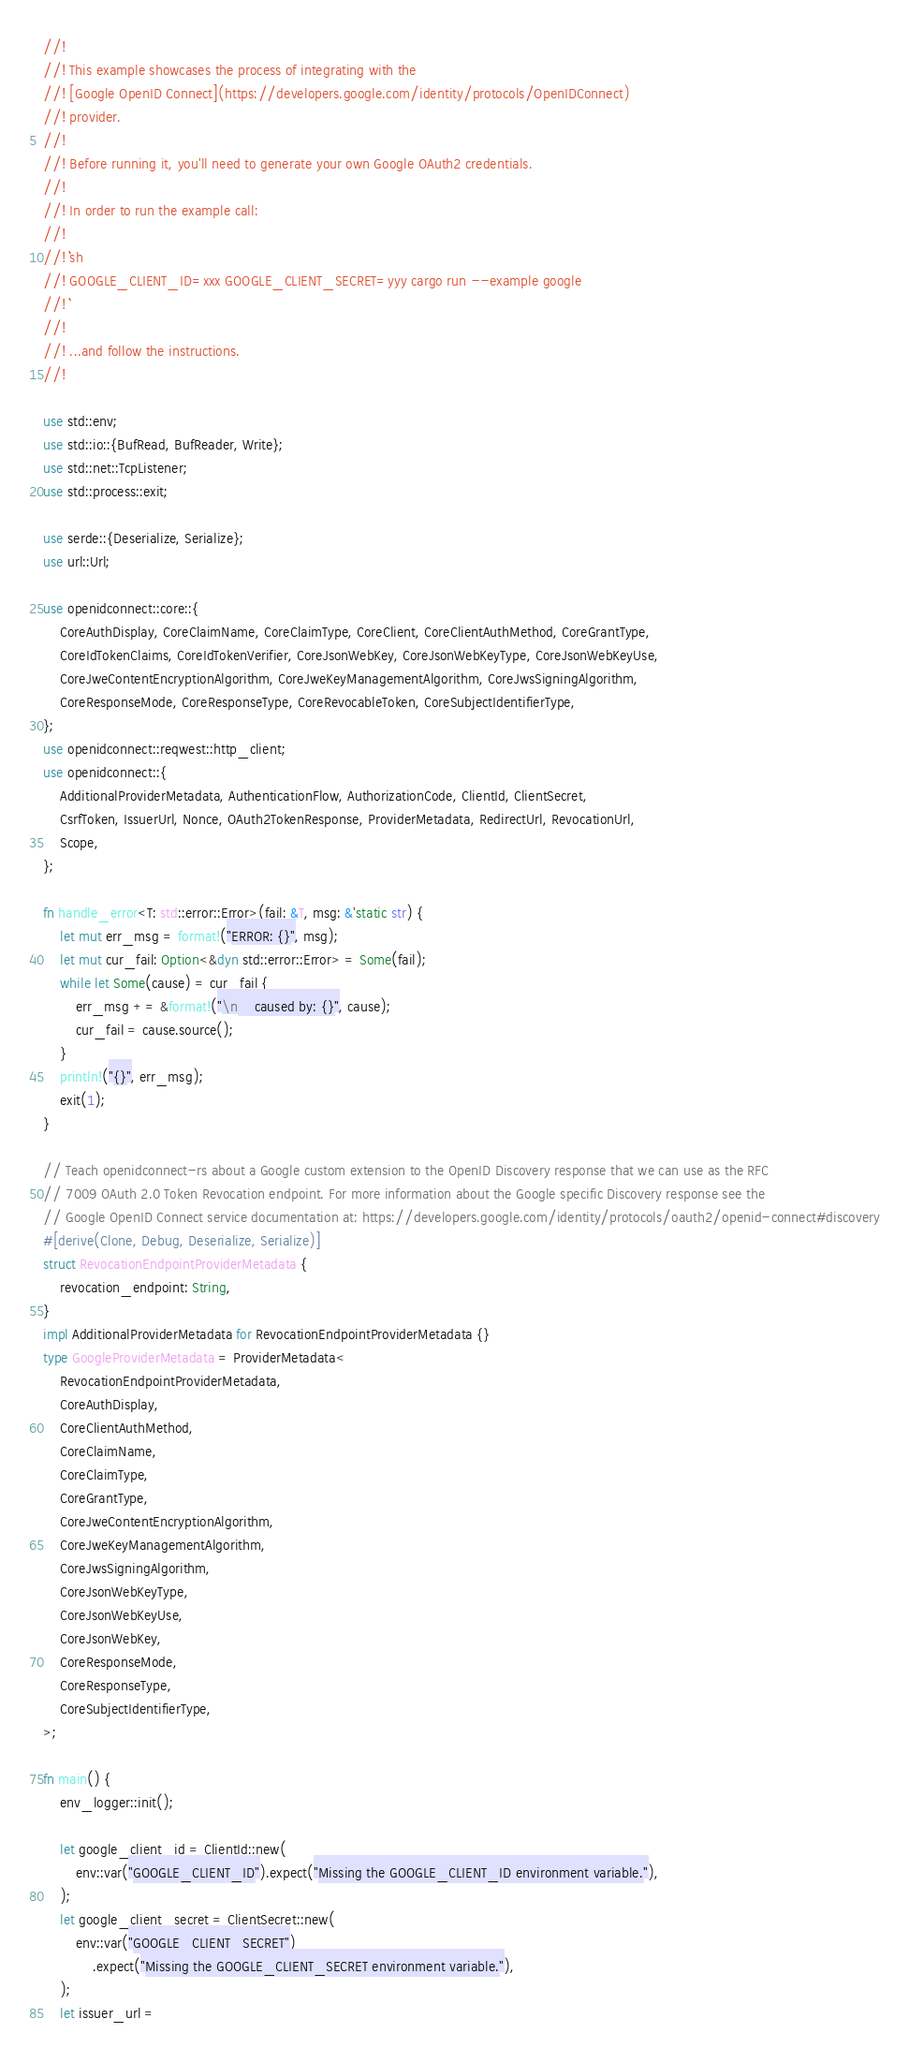<code> <loc_0><loc_0><loc_500><loc_500><_Rust_>//!
//! This example showcases the process of integrating with the
//! [Google OpenID Connect](https://developers.google.com/identity/protocols/OpenIDConnect)
//! provider.
//!
//! Before running it, you'll need to generate your own Google OAuth2 credentials.
//!
//! In order to run the example call:
//!
//! ```sh
//! GOOGLE_CLIENT_ID=xxx GOOGLE_CLIENT_SECRET=yyy cargo run --example google
//! ```
//!
//! ...and follow the instructions.
//!

use std::env;
use std::io::{BufRead, BufReader, Write};
use std::net::TcpListener;
use std::process::exit;

use serde::{Deserialize, Serialize};
use url::Url;

use openidconnect::core::{
    CoreAuthDisplay, CoreClaimName, CoreClaimType, CoreClient, CoreClientAuthMethod, CoreGrantType,
    CoreIdTokenClaims, CoreIdTokenVerifier, CoreJsonWebKey, CoreJsonWebKeyType, CoreJsonWebKeyUse,
    CoreJweContentEncryptionAlgorithm, CoreJweKeyManagementAlgorithm, CoreJwsSigningAlgorithm,
    CoreResponseMode, CoreResponseType, CoreRevocableToken, CoreSubjectIdentifierType,
};
use openidconnect::reqwest::http_client;
use openidconnect::{
    AdditionalProviderMetadata, AuthenticationFlow, AuthorizationCode, ClientId, ClientSecret,
    CsrfToken, IssuerUrl, Nonce, OAuth2TokenResponse, ProviderMetadata, RedirectUrl, RevocationUrl,
    Scope,
};

fn handle_error<T: std::error::Error>(fail: &T, msg: &'static str) {
    let mut err_msg = format!("ERROR: {}", msg);
    let mut cur_fail: Option<&dyn std::error::Error> = Some(fail);
    while let Some(cause) = cur_fail {
        err_msg += &format!("\n    caused by: {}", cause);
        cur_fail = cause.source();
    }
    println!("{}", err_msg);
    exit(1);
}

// Teach openidconnect-rs about a Google custom extension to the OpenID Discovery response that we can use as the RFC
// 7009 OAuth 2.0 Token Revocation endpoint. For more information about the Google specific Discovery response see the
// Google OpenID Connect service documentation at: https://developers.google.com/identity/protocols/oauth2/openid-connect#discovery
#[derive(Clone, Debug, Deserialize, Serialize)]
struct RevocationEndpointProviderMetadata {
    revocation_endpoint: String,
}
impl AdditionalProviderMetadata for RevocationEndpointProviderMetadata {}
type GoogleProviderMetadata = ProviderMetadata<
    RevocationEndpointProviderMetadata,
    CoreAuthDisplay,
    CoreClientAuthMethod,
    CoreClaimName,
    CoreClaimType,
    CoreGrantType,
    CoreJweContentEncryptionAlgorithm,
    CoreJweKeyManagementAlgorithm,
    CoreJwsSigningAlgorithm,
    CoreJsonWebKeyType,
    CoreJsonWebKeyUse,
    CoreJsonWebKey,
    CoreResponseMode,
    CoreResponseType,
    CoreSubjectIdentifierType,
>;

fn main() {
    env_logger::init();

    let google_client_id = ClientId::new(
        env::var("GOOGLE_CLIENT_ID").expect("Missing the GOOGLE_CLIENT_ID environment variable."),
    );
    let google_client_secret = ClientSecret::new(
        env::var("GOOGLE_CLIENT_SECRET")
            .expect("Missing the GOOGLE_CLIENT_SECRET environment variable."),
    );
    let issuer_url =</code> 